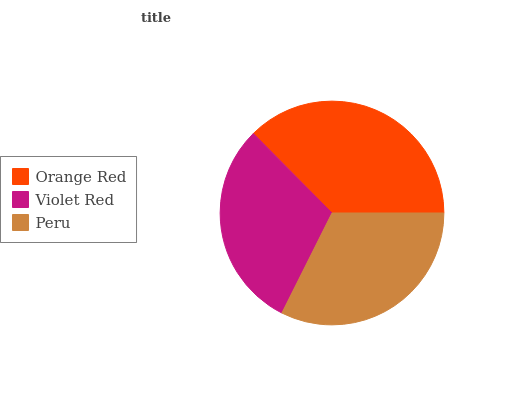Is Violet Red the minimum?
Answer yes or no. Yes. Is Orange Red the maximum?
Answer yes or no. Yes. Is Peru the minimum?
Answer yes or no. No. Is Peru the maximum?
Answer yes or no. No. Is Peru greater than Violet Red?
Answer yes or no. Yes. Is Violet Red less than Peru?
Answer yes or no. Yes. Is Violet Red greater than Peru?
Answer yes or no. No. Is Peru less than Violet Red?
Answer yes or no. No. Is Peru the high median?
Answer yes or no. Yes. Is Peru the low median?
Answer yes or no. Yes. Is Orange Red the high median?
Answer yes or no. No. Is Violet Red the low median?
Answer yes or no. No. 